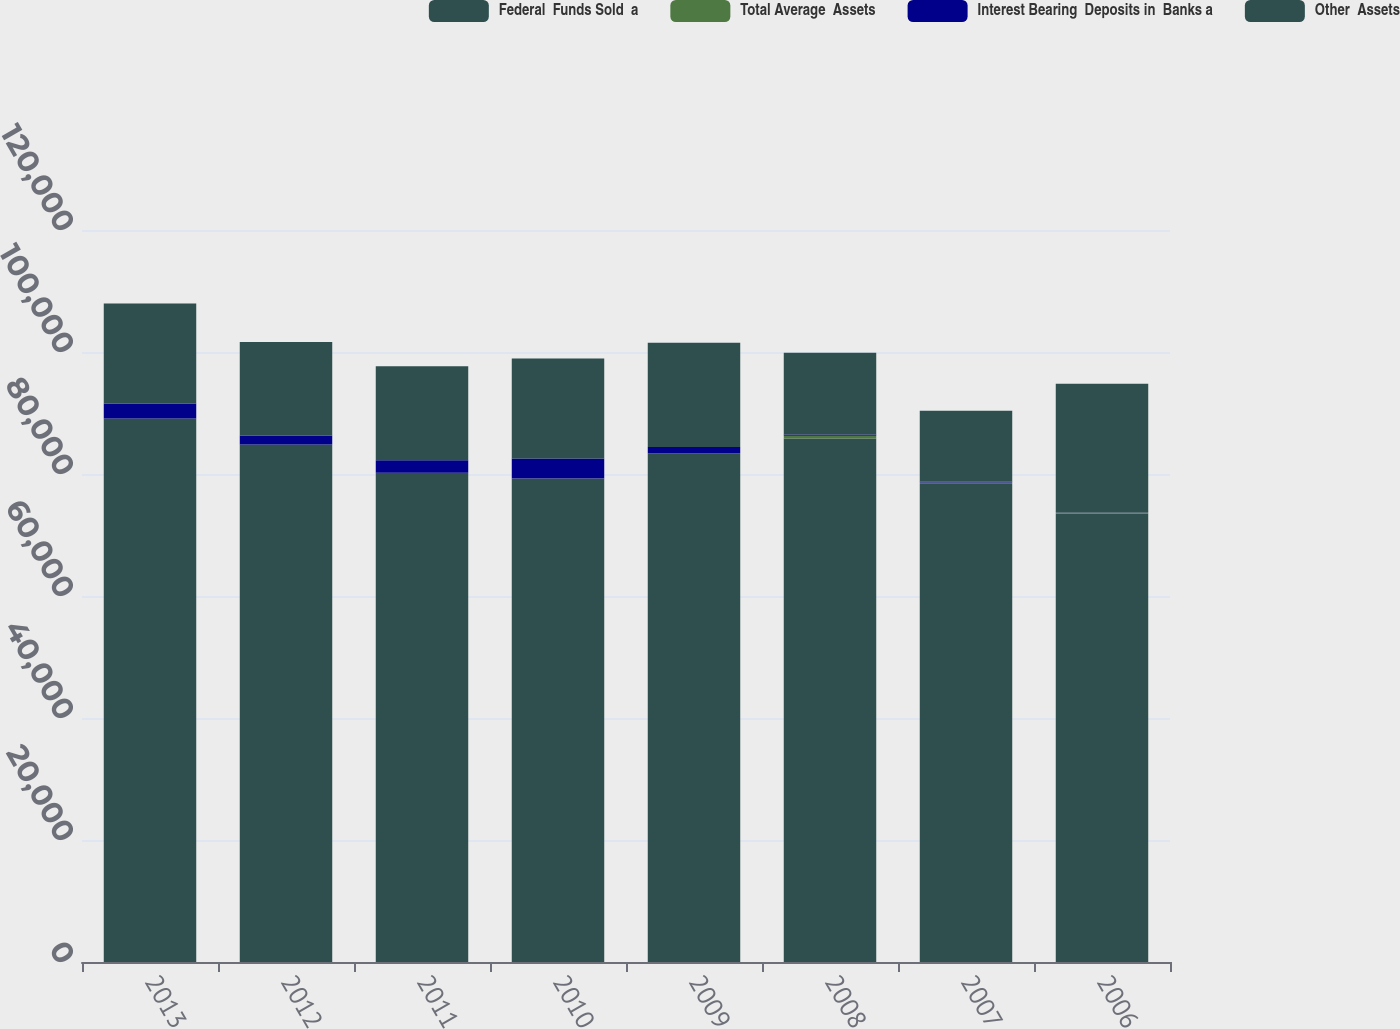<chart> <loc_0><loc_0><loc_500><loc_500><stacked_bar_chart><ecel><fcel>2013<fcel>2012<fcel>2011<fcel>2010<fcel>2009<fcel>2008<fcel>2007<fcel>2006<nl><fcel>Federal  Funds Sold  a<fcel>89093<fcel>84822<fcel>80214<fcel>79232<fcel>83391<fcel>85835<fcel>78348<fcel>73493<nl><fcel>Total Average  Assets<fcel>1<fcel>2<fcel>1<fcel>11<fcel>12<fcel>438<fcel>257<fcel>252<nl><fcel>Interest Bearing  Deposits in  Banks a<fcel>2416<fcel>1493<fcel>2030<fcel>3317<fcel>1023<fcel>183<fcel>147<fcel>144<nl><fcel>Other  Assets<fcel>16444<fcel>15319<fcel>15437<fcel>16371<fcel>17100<fcel>13424<fcel>11630<fcel>20910<nl></chart> 